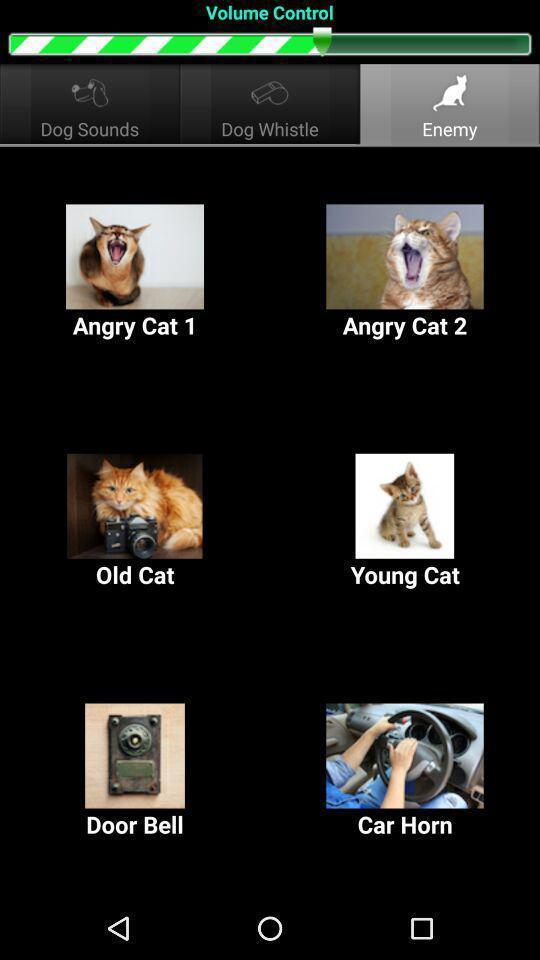Tell me about the visual elements in this screen capture. Screen shows multiple images. 